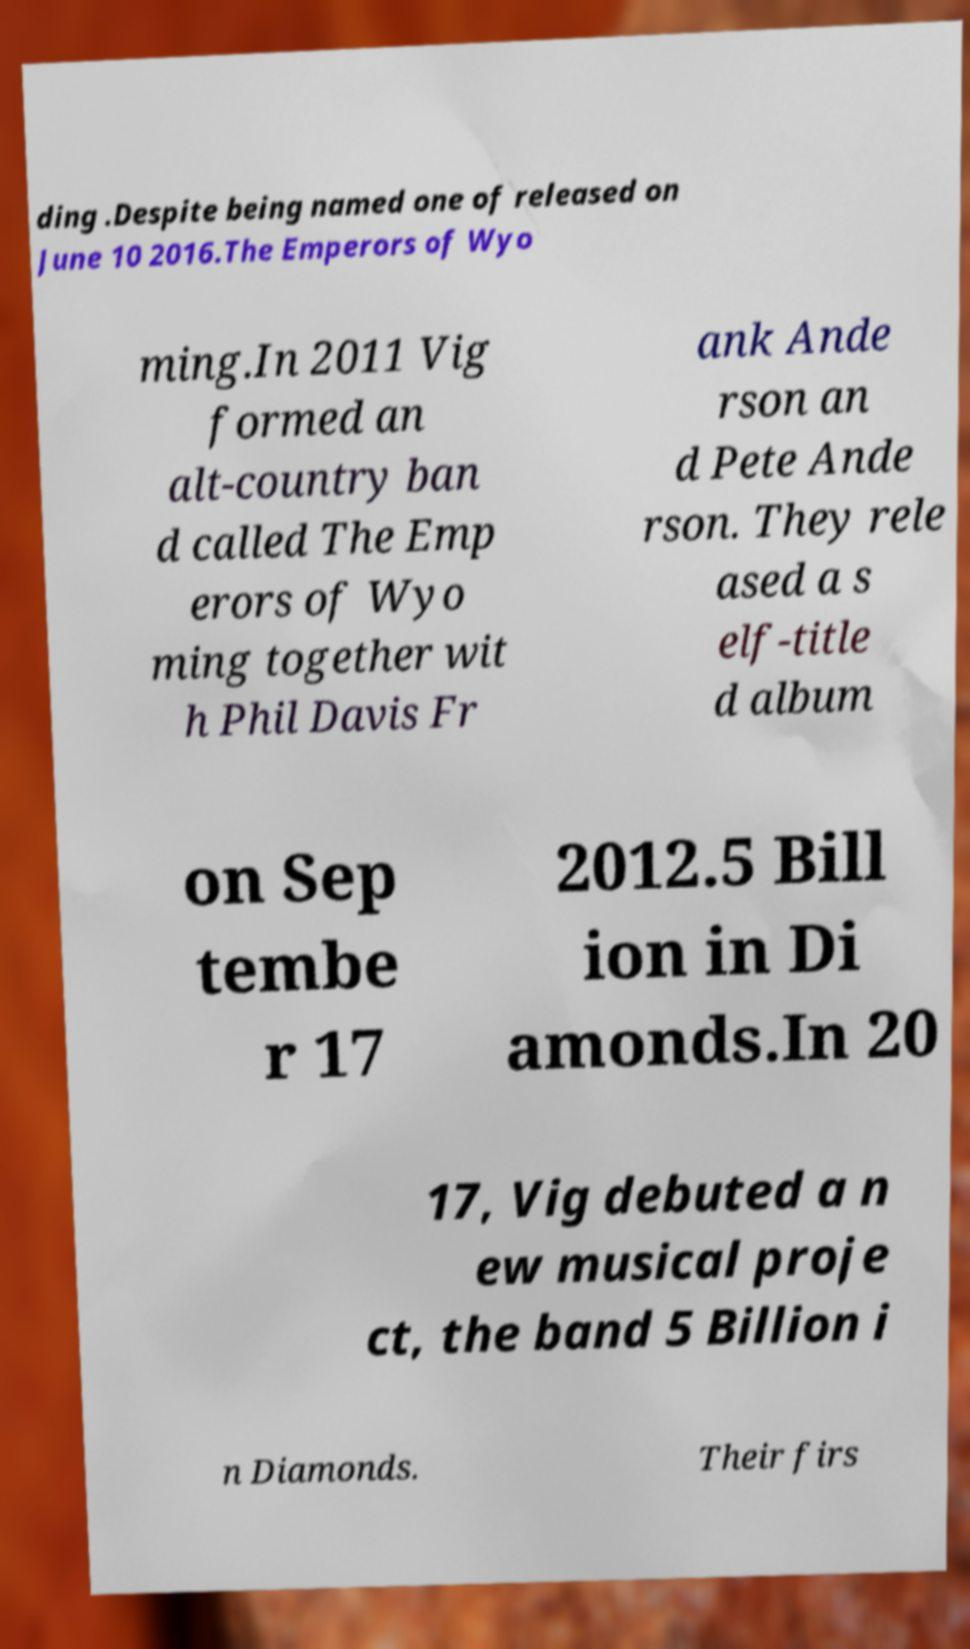There's text embedded in this image that I need extracted. Can you transcribe it verbatim? ding .Despite being named one of released on June 10 2016.The Emperors of Wyo ming.In 2011 Vig formed an alt-country ban d called The Emp erors of Wyo ming together wit h Phil Davis Fr ank Ande rson an d Pete Ande rson. They rele ased a s elf-title d album on Sep tembe r 17 2012.5 Bill ion in Di amonds.In 20 17, Vig debuted a n ew musical proje ct, the band 5 Billion i n Diamonds. Their firs 